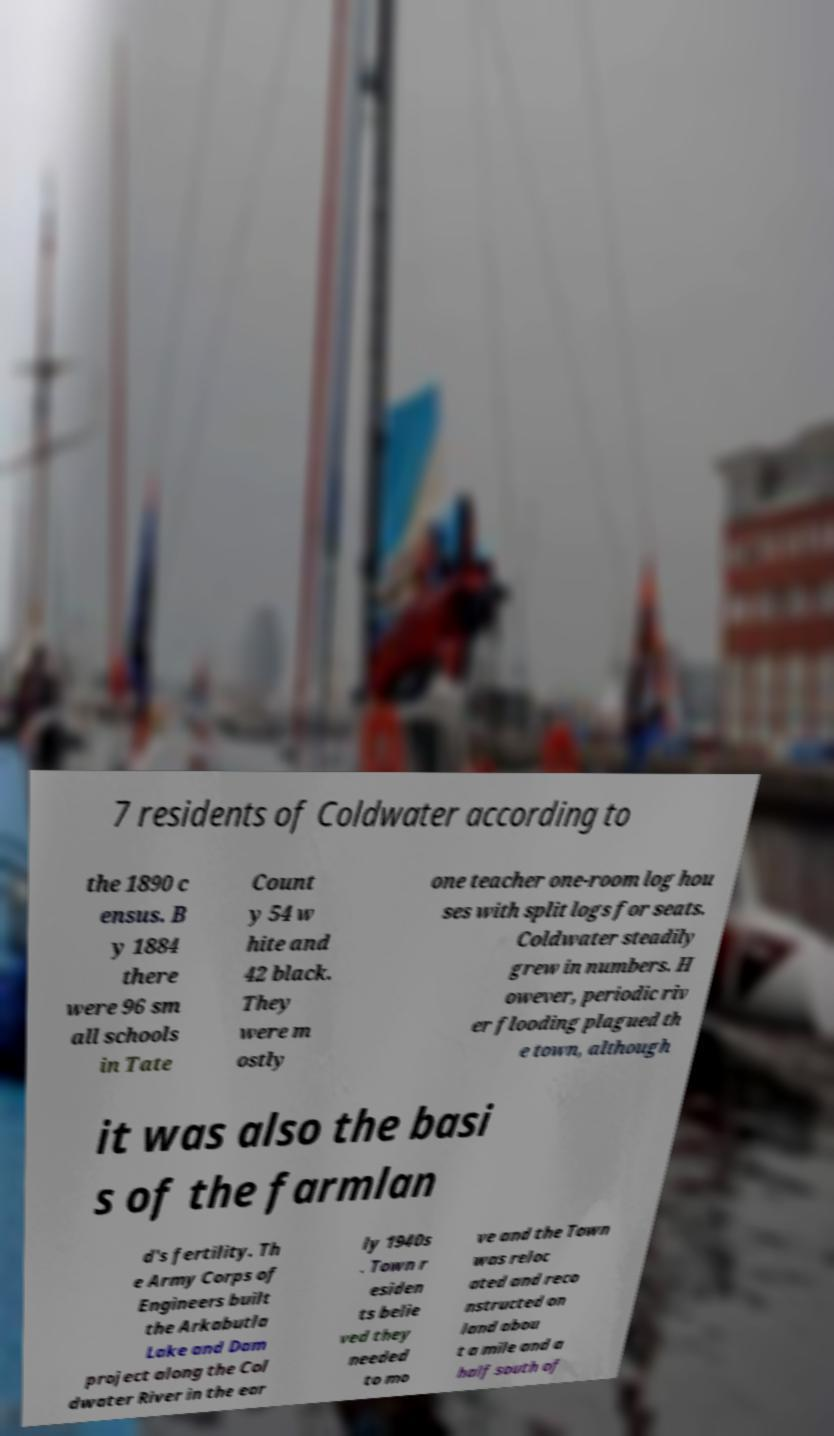Please read and relay the text visible in this image. What does it say? 7 residents of Coldwater according to the 1890 c ensus. B y 1884 there were 96 sm all schools in Tate Count y 54 w hite and 42 black. They were m ostly one teacher one-room log hou ses with split logs for seats. Coldwater steadily grew in numbers. H owever, periodic riv er flooding plagued th e town, although it was also the basi s of the farmlan d's fertility. Th e Army Corps of Engineers built the Arkabutla Lake and Dam project along the Col dwater River in the ear ly 1940s . Town r esiden ts belie ved they needed to mo ve and the Town was reloc ated and reco nstructed on land abou t a mile and a half south of 